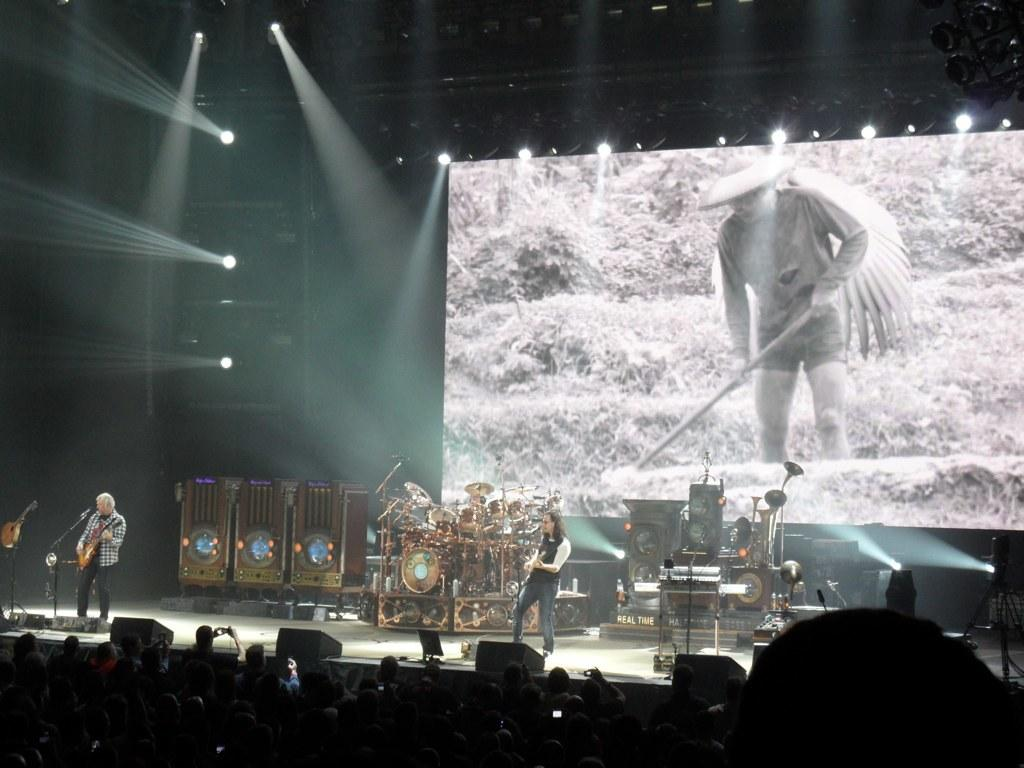What is the main subject of the image? The main subject of the image is a group of people. Can you describe the people in the background? There are two persons standing in the background. What else can be seen in the background? There are musical instruments, a projection screen, and lights visible in the background. What type of cookware is being used in the image? There is no cookware present in the image. Can you tell me how many baths are visible in the image? There are no baths visible in the image. 